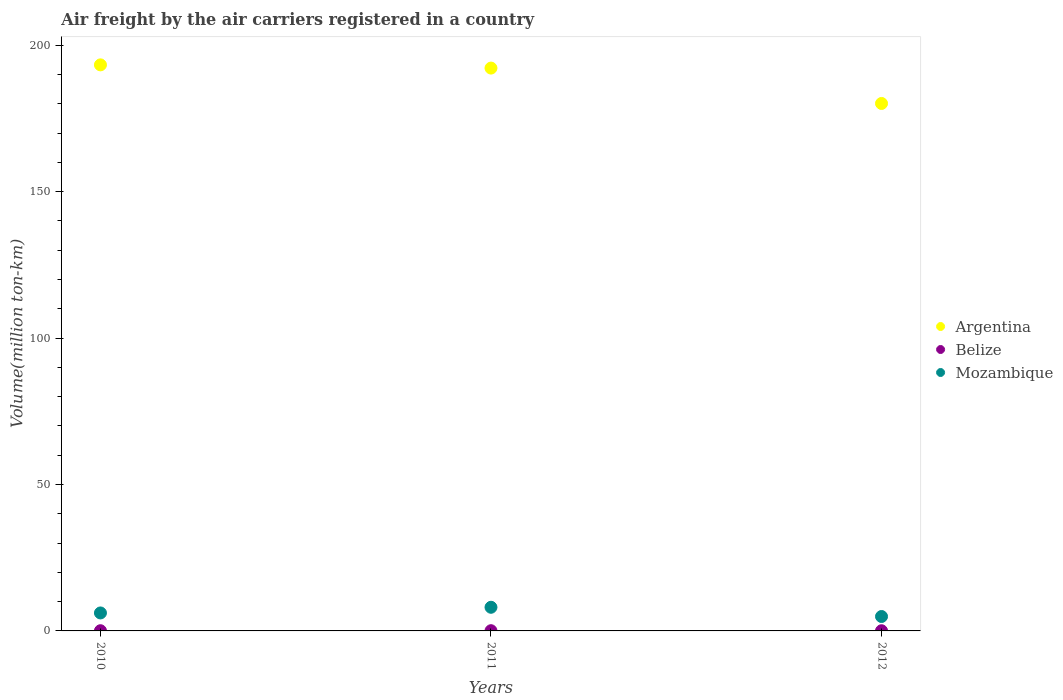How many different coloured dotlines are there?
Give a very brief answer. 3. Is the number of dotlines equal to the number of legend labels?
Provide a short and direct response. Yes. What is the volume of the air carriers in Belize in 2012?
Give a very brief answer. 0.06. Across all years, what is the maximum volume of the air carriers in Belize?
Your answer should be compact. 0.08. Across all years, what is the minimum volume of the air carriers in Argentina?
Your response must be concise. 180.12. In which year was the volume of the air carriers in Argentina minimum?
Your response must be concise. 2012. What is the total volume of the air carriers in Argentina in the graph?
Your answer should be very brief. 565.62. What is the difference between the volume of the air carriers in Belize in 2010 and that in 2011?
Offer a very short reply. -0.01. What is the difference between the volume of the air carriers in Belize in 2011 and the volume of the air carriers in Mozambique in 2010?
Make the answer very short. -6.06. What is the average volume of the air carriers in Belize per year?
Your answer should be very brief. 0.07. In the year 2010, what is the difference between the volume of the air carriers in Belize and volume of the air carriers in Mozambique?
Provide a succinct answer. -6.07. In how many years, is the volume of the air carriers in Mozambique greater than 130 million ton-km?
Ensure brevity in your answer.  0. What is the ratio of the volume of the air carriers in Mozambique in 2011 to that in 2012?
Your answer should be very brief. 1.64. Is the volume of the air carriers in Belize in 2011 less than that in 2012?
Your answer should be compact. No. Is the difference between the volume of the air carriers in Belize in 2011 and 2012 greater than the difference between the volume of the air carriers in Mozambique in 2011 and 2012?
Keep it short and to the point. No. What is the difference between the highest and the second highest volume of the air carriers in Belize?
Give a very brief answer. 0.01. What is the difference between the highest and the lowest volume of the air carriers in Belize?
Give a very brief answer. 0.01. Does the volume of the air carriers in Belize monotonically increase over the years?
Your answer should be very brief. No. Is the volume of the air carriers in Mozambique strictly greater than the volume of the air carriers in Belize over the years?
Provide a succinct answer. Yes. Is the volume of the air carriers in Mozambique strictly less than the volume of the air carriers in Argentina over the years?
Give a very brief answer. Yes. How many years are there in the graph?
Your answer should be compact. 3. What is the difference between two consecutive major ticks on the Y-axis?
Keep it short and to the point. 50. Where does the legend appear in the graph?
Ensure brevity in your answer.  Center right. What is the title of the graph?
Keep it short and to the point. Air freight by the air carriers registered in a country. Does "Marshall Islands" appear as one of the legend labels in the graph?
Keep it short and to the point. No. What is the label or title of the Y-axis?
Ensure brevity in your answer.  Volume(million ton-km). What is the Volume(million ton-km) of Argentina in 2010?
Your response must be concise. 193.3. What is the Volume(million ton-km) in Belize in 2010?
Your answer should be very brief. 0.07. What is the Volume(million ton-km) of Mozambique in 2010?
Your response must be concise. 6.14. What is the Volume(million ton-km) in Argentina in 2011?
Your answer should be compact. 192.2. What is the Volume(million ton-km) in Belize in 2011?
Offer a terse response. 0.08. What is the Volume(million ton-km) of Mozambique in 2011?
Offer a very short reply. 8.07. What is the Volume(million ton-km) of Argentina in 2012?
Make the answer very short. 180.12. What is the Volume(million ton-km) of Belize in 2012?
Your response must be concise. 0.06. What is the Volume(million ton-km) in Mozambique in 2012?
Your response must be concise. 4.92. Across all years, what is the maximum Volume(million ton-km) of Argentina?
Keep it short and to the point. 193.3. Across all years, what is the maximum Volume(million ton-km) of Belize?
Your response must be concise. 0.08. Across all years, what is the maximum Volume(million ton-km) of Mozambique?
Make the answer very short. 8.07. Across all years, what is the minimum Volume(million ton-km) in Argentina?
Ensure brevity in your answer.  180.12. Across all years, what is the minimum Volume(million ton-km) in Belize?
Provide a succinct answer. 0.06. Across all years, what is the minimum Volume(million ton-km) of Mozambique?
Provide a short and direct response. 4.92. What is the total Volume(million ton-km) of Argentina in the graph?
Keep it short and to the point. 565.62. What is the total Volume(million ton-km) in Belize in the graph?
Make the answer very short. 0.21. What is the total Volume(million ton-km) in Mozambique in the graph?
Give a very brief answer. 19.14. What is the difference between the Volume(million ton-km) of Argentina in 2010 and that in 2011?
Give a very brief answer. 1.1. What is the difference between the Volume(million ton-km) of Belize in 2010 and that in 2011?
Offer a very short reply. -0.01. What is the difference between the Volume(million ton-km) in Mozambique in 2010 and that in 2011?
Offer a terse response. -1.94. What is the difference between the Volume(million ton-km) of Argentina in 2010 and that in 2012?
Your answer should be compact. 13.18. What is the difference between the Volume(million ton-km) of Belize in 2010 and that in 2012?
Offer a very short reply. 0.01. What is the difference between the Volume(million ton-km) in Mozambique in 2010 and that in 2012?
Provide a short and direct response. 1.22. What is the difference between the Volume(million ton-km) in Argentina in 2011 and that in 2012?
Keep it short and to the point. 12.08. What is the difference between the Volume(million ton-km) of Belize in 2011 and that in 2012?
Provide a short and direct response. 0.01. What is the difference between the Volume(million ton-km) of Mozambique in 2011 and that in 2012?
Provide a succinct answer. 3.15. What is the difference between the Volume(million ton-km) in Argentina in 2010 and the Volume(million ton-km) in Belize in 2011?
Your answer should be compact. 193.23. What is the difference between the Volume(million ton-km) of Argentina in 2010 and the Volume(million ton-km) of Mozambique in 2011?
Your answer should be compact. 185.23. What is the difference between the Volume(million ton-km) in Belize in 2010 and the Volume(million ton-km) in Mozambique in 2011?
Ensure brevity in your answer.  -8.01. What is the difference between the Volume(million ton-km) in Argentina in 2010 and the Volume(million ton-km) in Belize in 2012?
Ensure brevity in your answer.  193.24. What is the difference between the Volume(million ton-km) in Argentina in 2010 and the Volume(million ton-km) in Mozambique in 2012?
Your answer should be compact. 188.38. What is the difference between the Volume(million ton-km) in Belize in 2010 and the Volume(million ton-km) in Mozambique in 2012?
Your answer should be compact. -4.85. What is the difference between the Volume(million ton-km) in Argentina in 2011 and the Volume(million ton-km) in Belize in 2012?
Make the answer very short. 192.14. What is the difference between the Volume(million ton-km) of Argentina in 2011 and the Volume(million ton-km) of Mozambique in 2012?
Your response must be concise. 187.28. What is the difference between the Volume(million ton-km) in Belize in 2011 and the Volume(million ton-km) in Mozambique in 2012?
Keep it short and to the point. -4.85. What is the average Volume(million ton-km) in Argentina per year?
Provide a succinct answer. 188.54. What is the average Volume(million ton-km) of Belize per year?
Your answer should be very brief. 0.07. What is the average Volume(million ton-km) in Mozambique per year?
Your answer should be compact. 6.38. In the year 2010, what is the difference between the Volume(million ton-km) in Argentina and Volume(million ton-km) in Belize?
Provide a short and direct response. 193.23. In the year 2010, what is the difference between the Volume(million ton-km) of Argentina and Volume(million ton-km) of Mozambique?
Ensure brevity in your answer.  187.16. In the year 2010, what is the difference between the Volume(million ton-km) in Belize and Volume(million ton-km) in Mozambique?
Provide a short and direct response. -6.07. In the year 2011, what is the difference between the Volume(million ton-km) in Argentina and Volume(million ton-km) in Belize?
Your answer should be compact. 192.13. In the year 2011, what is the difference between the Volume(million ton-km) of Argentina and Volume(million ton-km) of Mozambique?
Your answer should be compact. 184.13. In the year 2011, what is the difference between the Volume(million ton-km) in Belize and Volume(million ton-km) in Mozambique?
Your answer should be compact. -8. In the year 2012, what is the difference between the Volume(million ton-km) of Argentina and Volume(million ton-km) of Belize?
Your answer should be compact. 180.06. In the year 2012, what is the difference between the Volume(million ton-km) of Argentina and Volume(million ton-km) of Mozambique?
Your response must be concise. 175.2. In the year 2012, what is the difference between the Volume(million ton-km) in Belize and Volume(million ton-km) in Mozambique?
Make the answer very short. -4.86. What is the ratio of the Volume(million ton-km) of Belize in 2010 to that in 2011?
Give a very brief answer. 0.93. What is the ratio of the Volume(million ton-km) in Mozambique in 2010 to that in 2011?
Provide a succinct answer. 0.76. What is the ratio of the Volume(million ton-km) in Argentina in 2010 to that in 2012?
Your response must be concise. 1.07. What is the ratio of the Volume(million ton-km) of Belize in 2010 to that in 2012?
Give a very brief answer. 1.15. What is the ratio of the Volume(million ton-km) of Mozambique in 2010 to that in 2012?
Your answer should be very brief. 1.25. What is the ratio of the Volume(million ton-km) in Argentina in 2011 to that in 2012?
Your answer should be compact. 1.07. What is the ratio of the Volume(million ton-km) of Belize in 2011 to that in 2012?
Your answer should be compact. 1.23. What is the ratio of the Volume(million ton-km) in Mozambique in 2011 to that in 2012?
Ensure brevity in your answer.  1.64. What is the difference between the highest and the second highest Volume(million ton-km) in Belize?
Your answer should be very brief. 0.01. What is the difference between the highest and the second highest Volume(million ton-km) of Mozambique?
Ensure brevity in your answer.  1.94. What is the difference between the highest and the lowest Volume(million ton-km) of Argentina?
Make the answer very short. 13.18. What is the difference between the highest and the lowest Volume(million ton-km) of Belize?
Keep it short and to the point. 0.01. What is the difference between the highest and the lowest Volume(million ton-km) of Mozambique?
Offer a terse response. 3.15. 